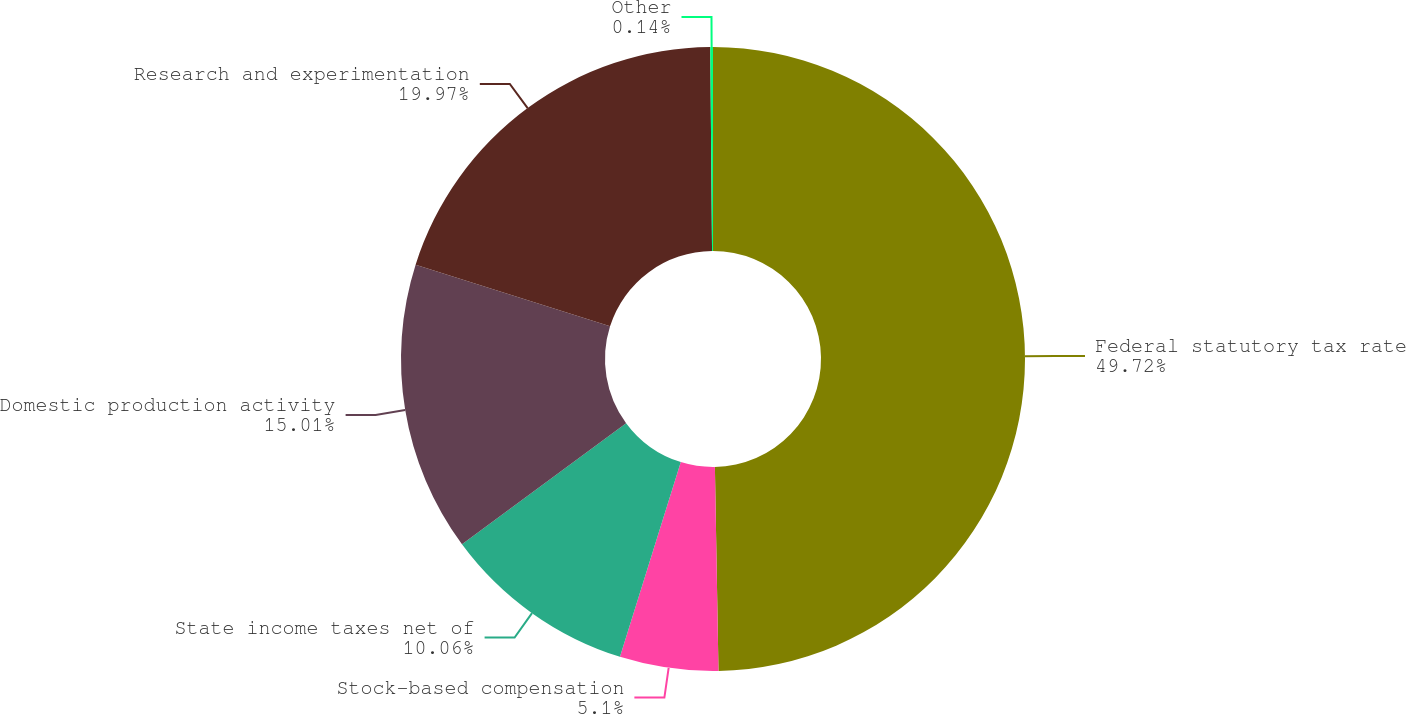<chart> <loc_0><loc_0><loc_500><loc_500><pie_chart><fcel>Federal statutory tax rate<fcel>Stock-based compensation<fcel>State income taxes net of<fcel>Domestic production activity<fcel>Research and experimentation<fcel>Other<nl><fcel>49.72%<fcel>5.1%<fcel>10.06%<fcel>15.01%<fcel>19.97%<fcel>0.14%<nl></chart> 